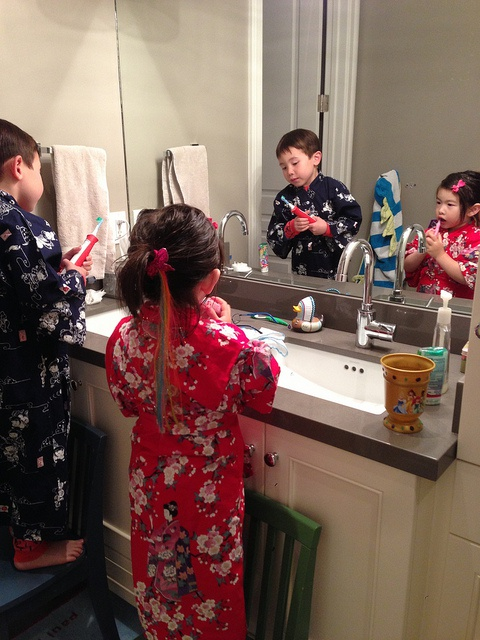Describe the objects in this image and their specific colors. I can see people in tan, maroon, black, and brown tones, people in tan, black, maroon, gray, and navy tones, chair in tan, black, darkblue, and maroon tones, chair in tan, black, and darkgreen tones, and people in tan, black, gray, salmon, and brown tones in this image. 